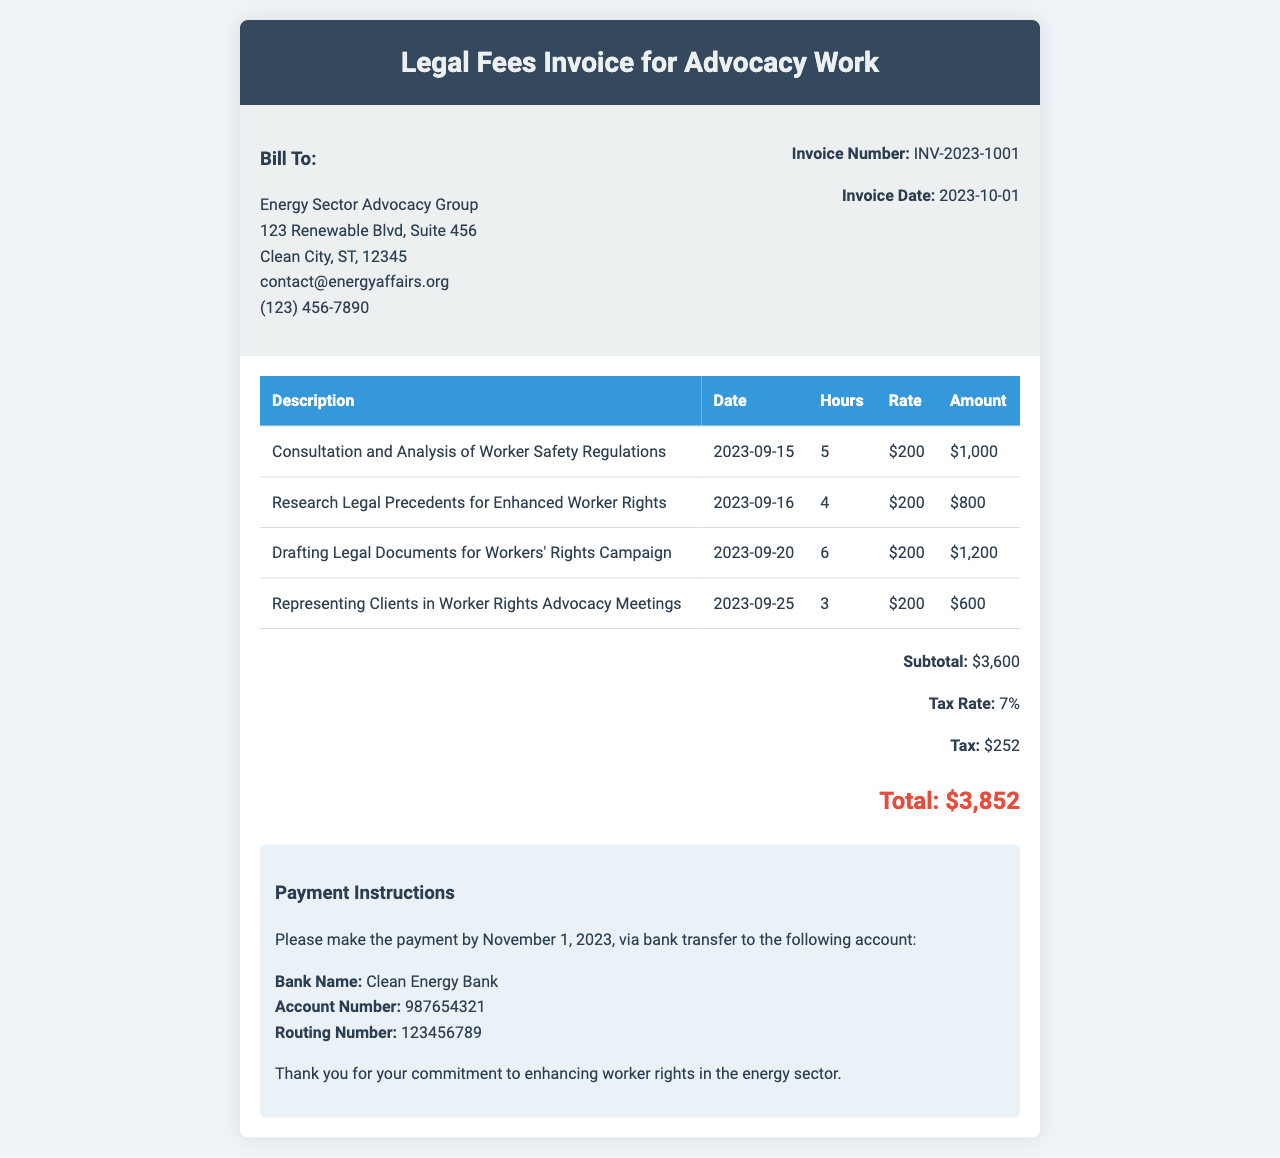What is the invoice number? The invoice number is specified in the document under "Invoice Number:" which identifies this particular invoice.
Answer: INV-2023-1001 What is the invoice date? The invoice date is mentioned in the document as the date when the invoice was issued.
Answer: 2023-10-01 How many hours were billed for drafting legal documents? The document lists the hours for each service, and for drafting legal documents it shows "6" hours.
Answer: 6 What is the subtotal amount? The subtotal amount is provided in the summary section of the invoice, indicating the total before tax.
Answer: $3,600 What is the tax rate? The tax rate is specified in the summary section and indicates the percentage of tax applied to the subtotal.
Answer: 7% Who should the payment be made to? The document specifies who the payment should be made to under "Payment Instructions".
Answer: Clean Energy Bank What type of advocacy work is this invoice related to? The invoice indicates it is for legal fees concerning the advocacy of workers' rights in the energy sector.
Answer: Enhanced workers' rights What is the total amount due? The total amount due is the final figure provided in the summary after adding tax to the subtotal.
Answer: $3,852 What is the due date for the payment? The due date for the payment is mentioned in the payment instructions section, indicating when the payment needs to be completed.
Answer: November 1, 2023 What is the total number of hours billed for services? The total hours can be calculated by adding up the hours listed for each service in the table provided in the document.
Answer: 18 